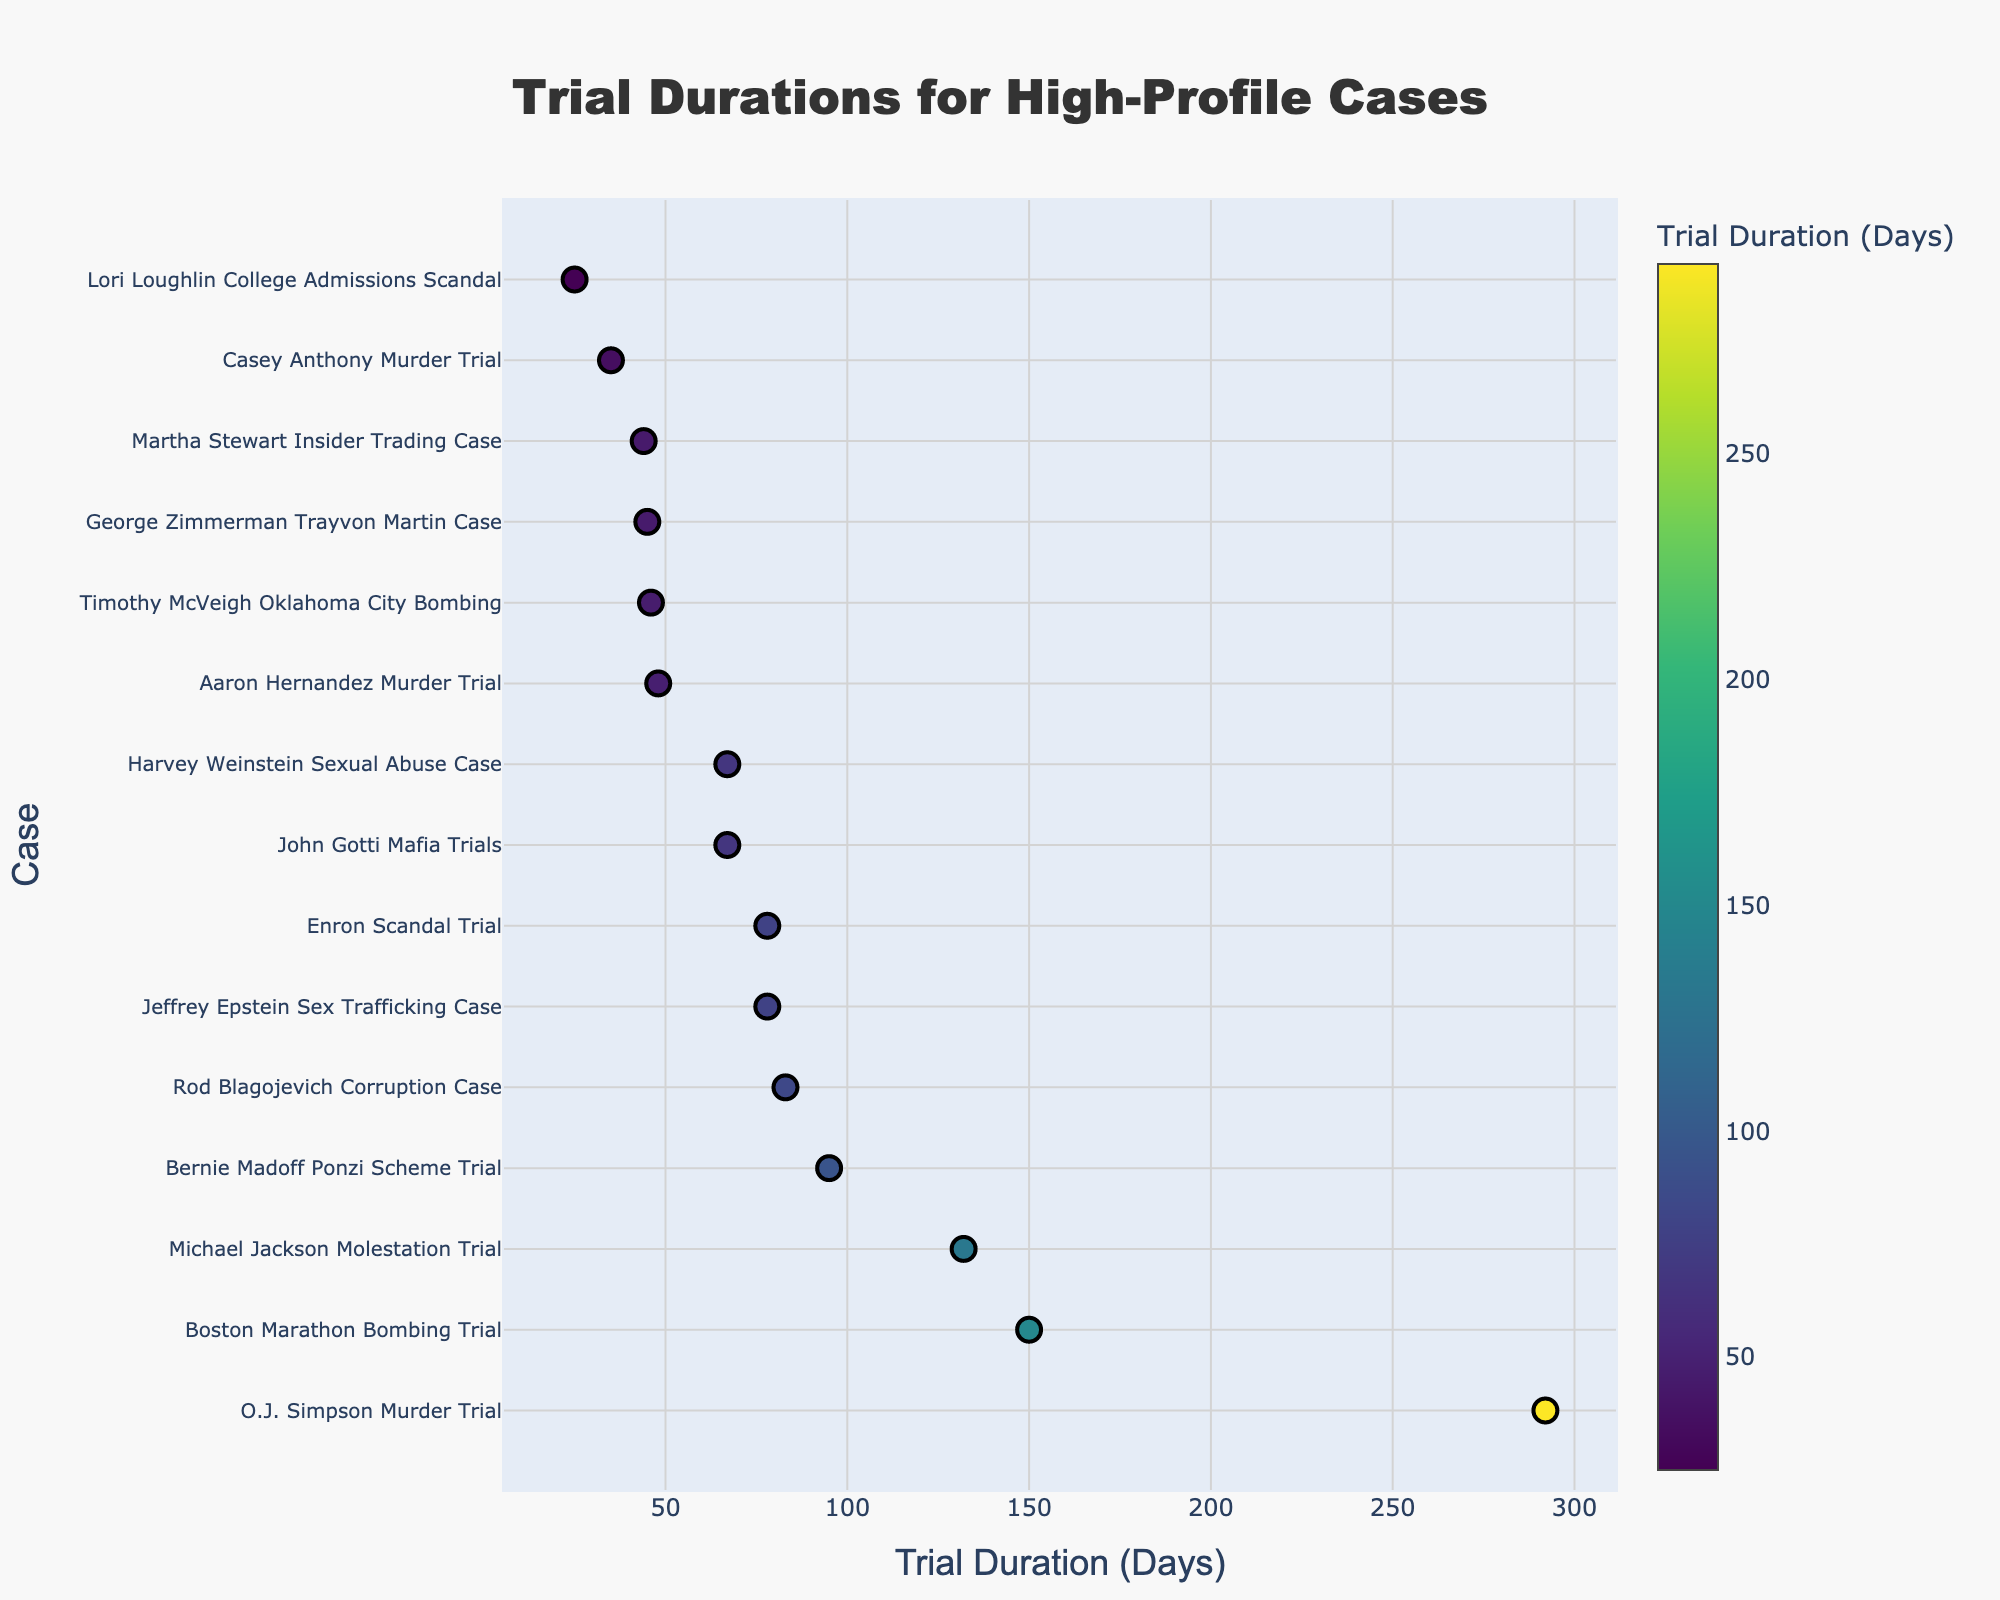What is the trial duration for the O.J. Simpson Murder Trial? The plot shows a dot representing the O.J. Simpson Murder Trial with its duration on the x-axis. By locating this dot, the trial duration can be read directly.
Answer: 292 days Which city had the most high-profile trials listed in the plot? By counting the dots associated with each city listed in the plot, the city with the most cases can be determined. New York City has multiple dots.
Answer: New York What is the difference in trial duration between the O.J. Simpson Murder Trial and the Lori Loughlin College Admissions Scandal? By locating the dots for both cases and noting their positions on the x-axis, the difference in days can be calculated: 292 - 25 = 267 days.
Answer: 267 days Which trial had the shortest duration, and how long was it? Identify the dot representing the shortest duration on the x-axis and refer to its label; the dot on the far-left end is Lori Loughlin’s trial, lasting 25 days.
Answer: Lori Loughlin, 25 days What is the average duration of trials in New York? Identify all trials in New York: Bernie Madoff (95), John Gotti (67), Martha Stewart (44), Jeffrey Epstein (78), Harvey Weinstein (67). Sum these durations and divide by the number of trials: (95 + 67 + 44 + 78 + 67) / 5.
Answer: 70.2 days Compare the trial durations of the Bernie Madoff Ponzi Scheme Trial and the Michael Jackson Molestation Trial. Which was longer and by how many days? Locate both dots on the x-axis: Bernie Madoff is at 95 days, Michael Jackson is at 132 days. Subtract the smaller number from the larger to get the difference: 132 - 95 = 37 days.
Answer: Michael Jackson, 37 days How many trials had durations longer than 100 days? Identify the dots positioned beyond the 100 days mark on the x-axis: O.J. Simpson, Michael Jackson, Boston Marathon Bombing. Count these dots.
Answer: 3 trials Which case in Boston had a longer trial duration, and what was its duration? Locate the dots labeled for Boston: Boston Marathon Bombing (150), Aaron Hernandez (48). Compare their x-axis positions and durations.
Answer: Boston Marathon Bombing, 150 days What's the total trial duration of both Boston trials combined? Sum the durations of the Boston trials: Boston Marathon Bombing (150) and Aaron Hernandez (48). 150 + 48 = 198.
Answer: 198 days Which trial in New York had the shortest duration, and how long was it? Compare the dots for New York cases: Bernie Madoff (95), John Gotti (67), Martha Stewart (44), Jeffrey Epstein (78), Harvey Weinstein (67). The shortest trial is Martha Stewart's, lasting 44 days.
Answer: Martha Stewart, 44 days 